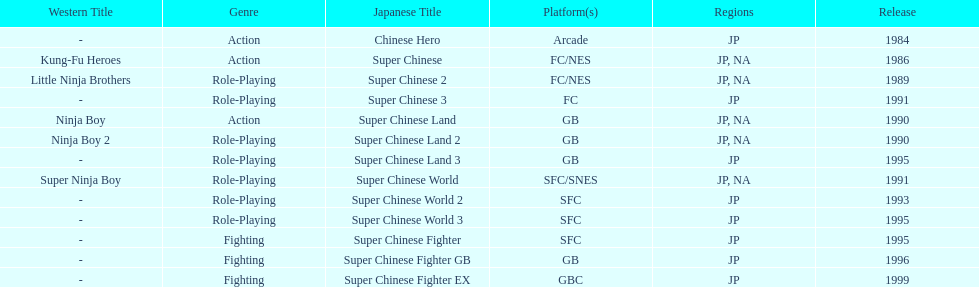When was the most recent super chinese game launched? 1999. 